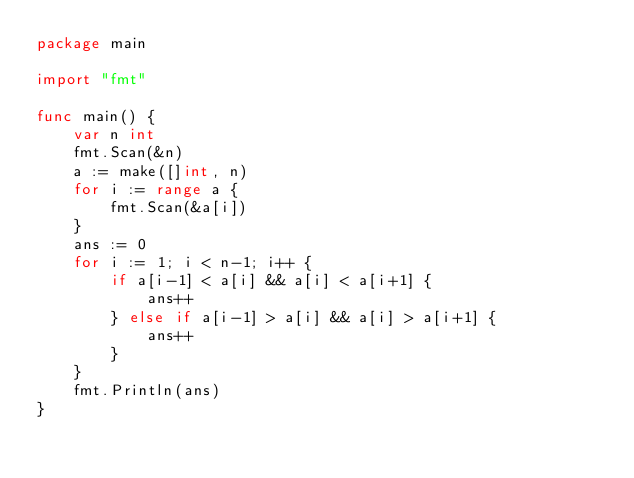Convert code to text. <code><loc_0><loc_0><loc_500><loc_500><_Go_>package main

import "fmt"

func main() {
	var n int
	fmt.Scan(&n)
	a := make([]int, n)
	for i := range a {
		fmt.Scan(&a[i])
	}
	ans := 0
	for i := 1; i < n-1; i++ {
		if a[i-1] < a[i] && a[i] < a[i+1] {
			ans++
		} else if a[i-1] > a[i] && a[i] > a[i+1] {
			ans++
		}
	}
	fmt.Println(ans)
}
</code> 